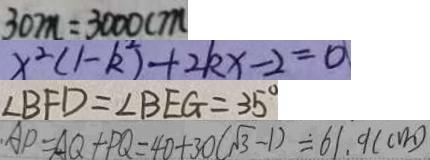<formula> <loc_0><loc_0><loc_500><loc_500>3 0 m = 3 0 0 0 c m 
 x ^ { 2 } ( 1 - k ^ { 2 } ) + 2 k x - 2 = 0 
 \angle B F D = \angle B E G = 3 5 ^ { \circ } 
 A P = A Q + P Q = 4 0 + 3 0 ( \sqrt { 3 } - 1 ) = 6 1 . 9 ( c m )</formula> 